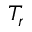<formula> <loc_0><loc_0><loc_500><loc_500>T _ { r }</formula> 